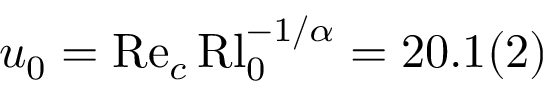<formula> <loc_0><loc_0><loc_500><loc_500>u _ { 0 } = R e _ { c } \, R l _ { 0 } ^ { - 1 / \alpha } = 2 0 . 1 ( 2 )</formula> 